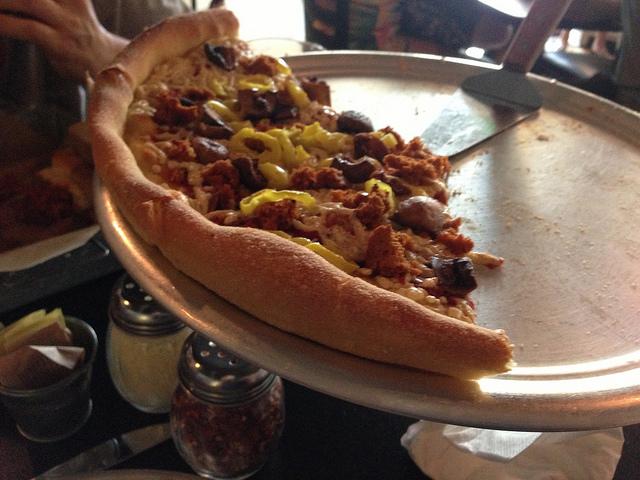How many slices are left?
Keep it brief. 3. Are there banana peppers on the pizza?
Give a very brief answer. Yes. Is this delicious?
Write a very short answer. Yes. What condiments are there?
Quick response, please. Pineapple chicken black olives. 